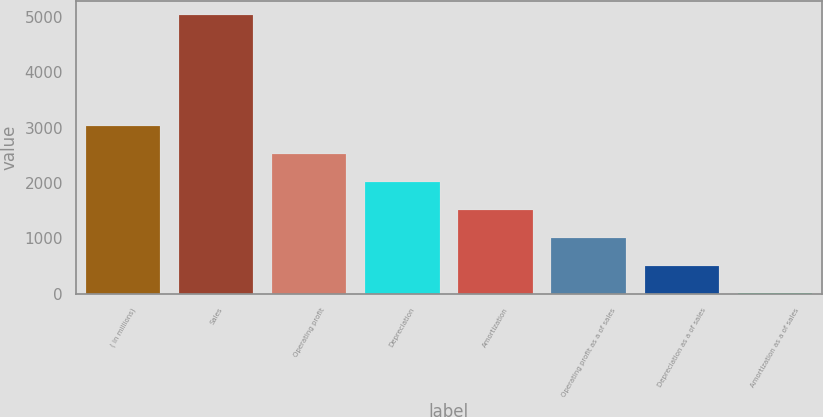<chart> <loc_0><loc_0><loc_500><loc_500><bar_chart><fcel>( in millions)<fcel>Sales<fcel>Operating profit<fcel>Depreciation<fcel>Amortization<fcel>Operating profit as a of sales<fcel>Depreciation as a of sales<fcel>Amortization as a of sales<nl><fcel>3024.18<fcel>5038.3<fcel>2520.65<fcel>2017.12<fcel>1513.59<fcel>1010.06<fcel>506.53<fcel>3<nl></chart> 